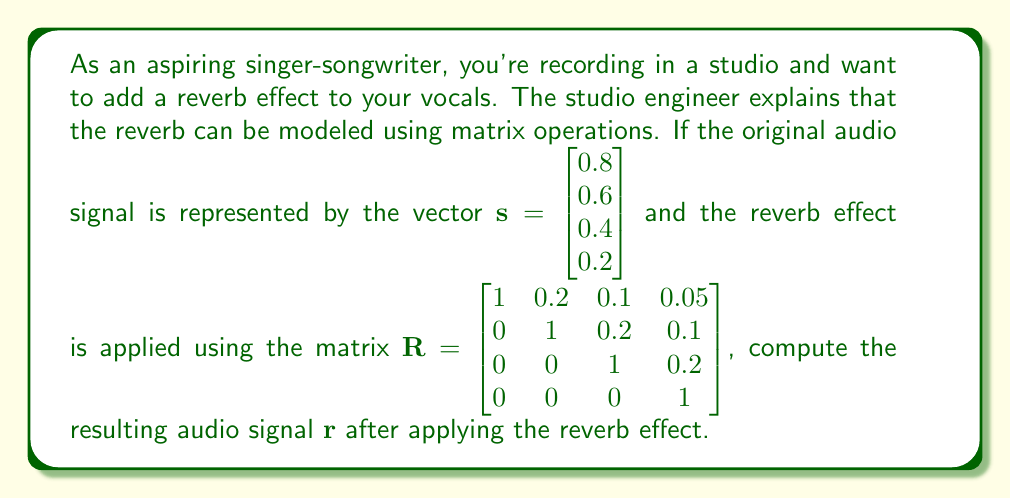Help me with this question. To compute the reverb effect, we need to multiply the reverb matrix $\mathbf{R}$ by the original audio signal vector $\mathbf{s}$. This operation can be represented as:

$$\mathbf{r} = \mathbf{R}\mathbf{s}$$

Let's perform the matrix multiplication step by step:

$$\begin{align*}
\mathbf{r} &= \begin{bmatrix} 
1 & 0.2 & 0.1 & 0.05 \\ 
0 & 1 & 0.2 & 0.1 \\ 
0 & 0 & 1 & 0.2 \\ 
0 & 0 & 0 & 1 
\end{bmatrix} \begin{bmatrix} 
0.8 \\ 0.6 \\ 0.4 \\ 0.2 
\end{bmatrix} \\[2ex]
&= \begin{bmatrix}
(1 \times 0.8) + (0.2 \times 0.6) + (0.1 \times 0.4) + (0.05 \times 0.2) \\
(0 \times 0.8) + (1 \times 0.6) + (0.2 \times 0.4) + (0.1 \times 0.2) \\
(0 \times 0.8) + (0 \times 0.6) + (1 \times 0.4) + (0.2 \times 0.2) \\
(0 \times 0.8) + (0 \times 0.6) + (0 \times 0.4) + (1 \times 0.2)
\end{bmatrix} \\[2ex]
&= \begin{bmatrix}
0.8 + 0.12 + 0.04 + 0.01 \\
0 + 0.6 + 0.08 + 0.02 \\
0 + 0 + 0.4 + 0.04 \\
0 + 0 + 0 + 0.2
\end{bmatrix} \\[2ex]
&= \begin{bmatrix}
0.97 \\
0.70 \\
0.44 \\
0.20
\end{bmatrix}
\end{align*}$$

The resulting audio signal $\mathbf{r}$ after applying the reverb effect is the vector shown in the final step of the calculation.
Answer: $$\mathbf{r} = \begin{bmatrix} 0.97 \\ 0.70 \\ 0.44 \\ 0.20 \end{bmatrix}$$ 